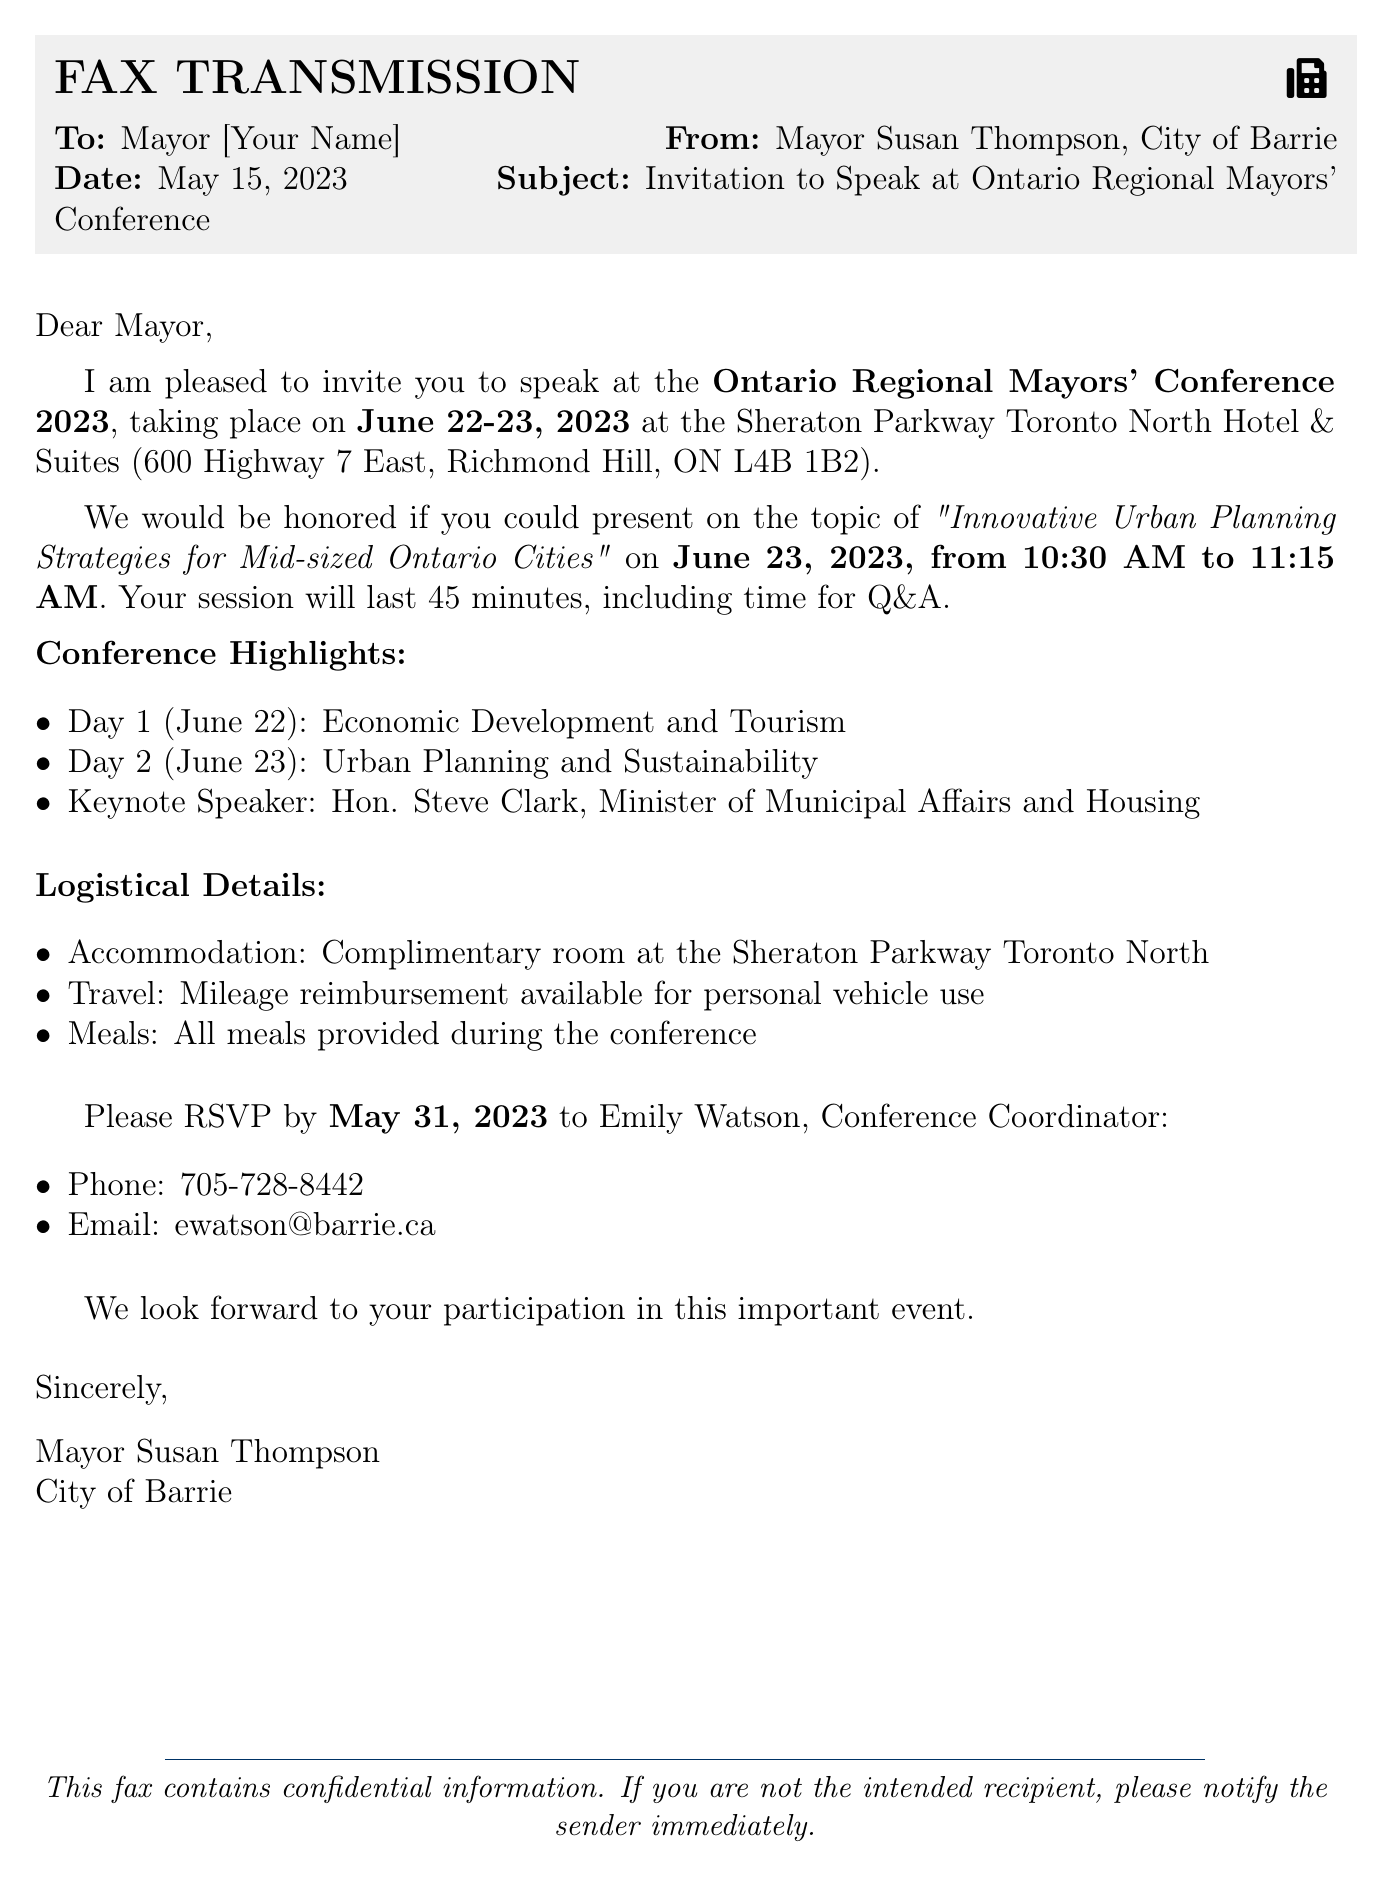What is the date of the conference? The conference is scheduled for June 22-23, 2023.
Answer: June 22-23, 2023 Who is the keynote speaker? The document states that Hon. Steve Clark, Minister of Municipal Affairs and Housing, is the keynote speaker.
Answer: Hon. Steve Clark What topic will the mayor speak on? The invited presentation topic is "Innovative Urban Planning Strategies for Mid-sized Ontario Cities."
Answer: Innovative Urban Planning Strategies for Mid-sized Ontario Cities When is the mayor's presentation scheduled? The presentation is scheduled for June 23, 2023, from 10:30 AM to 11:15 AM.
Answer: June 23, 2023, from 10:30 AM to 11:15 AM What is provided in terms of accommodation? The conference offers a complimentary room at the Sheraton Parkway Toronto North.
Answer: Complimentary room What is the RSVP deadline? The RSVP deadline mentioned in the document is May 31, 2023.
Answer: May 31, 2023 What are the meal arrangements during the conference? The document indicates that all meals are provided during the conference.
Answer: All meals provided What is the purpose of this fax? The primary purpose of this fax is to invite the mayor to speak at the Ontario Regional Mayors' Conference.
Answer: Invitation to speak What should attendees do if they are not the intended recipient? The document advises that if an individual is not the intended recipient, they should notify the sender immediately.
Answer: Notify the sender immediately 